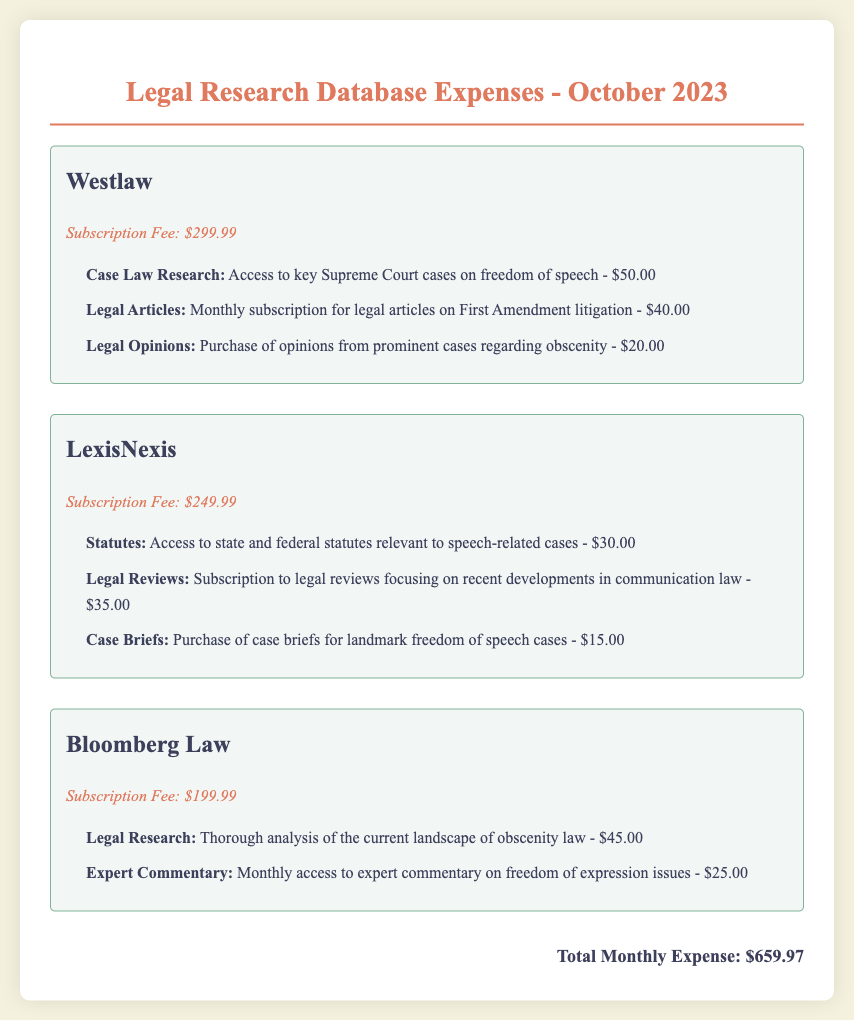What is the title of the document? The title is prominently displayed at the top of the document, indicating its content and purpose.
Answer: Legal Research Database Expenses - October 2023 How much is the subscription fee for Westlaw? The document specifies the subscription fee for each database, including Westlaw.
Answer: $299.99 What charges are itemized under LexisNexis? The document lists specific charges for LexisNexis, summarized in the relevant section.
Answer: Statutes, Legal Reviews, Case Briefs What is the total monthly expense? The total is calculated based on the sum of all subscription fees and charges listed in the document.
Answer: $659.97 Which database has the highest subscription fee? Each database's subscription fee is compared to determine which is the highest.
Answer: Westlaw How much for access to key Supreme Court cases on freedom of speech? This information is found within the charge items listed under Westlaw.
Answer: $50.00 What is one item purchased from Bloomberg Law? The document lists specific services under Bloomberg Law, highlighting different items available.
Answer: Legal Research How much was paid for legal articles on First Amendment litigation? The document includes specific amounts for various charges related to legal articles.
Answer: $40.00 What is the subscription fee for Bloomberg Law? The individual subscription fees for each service are documented clearly.
Answer: $199.99 